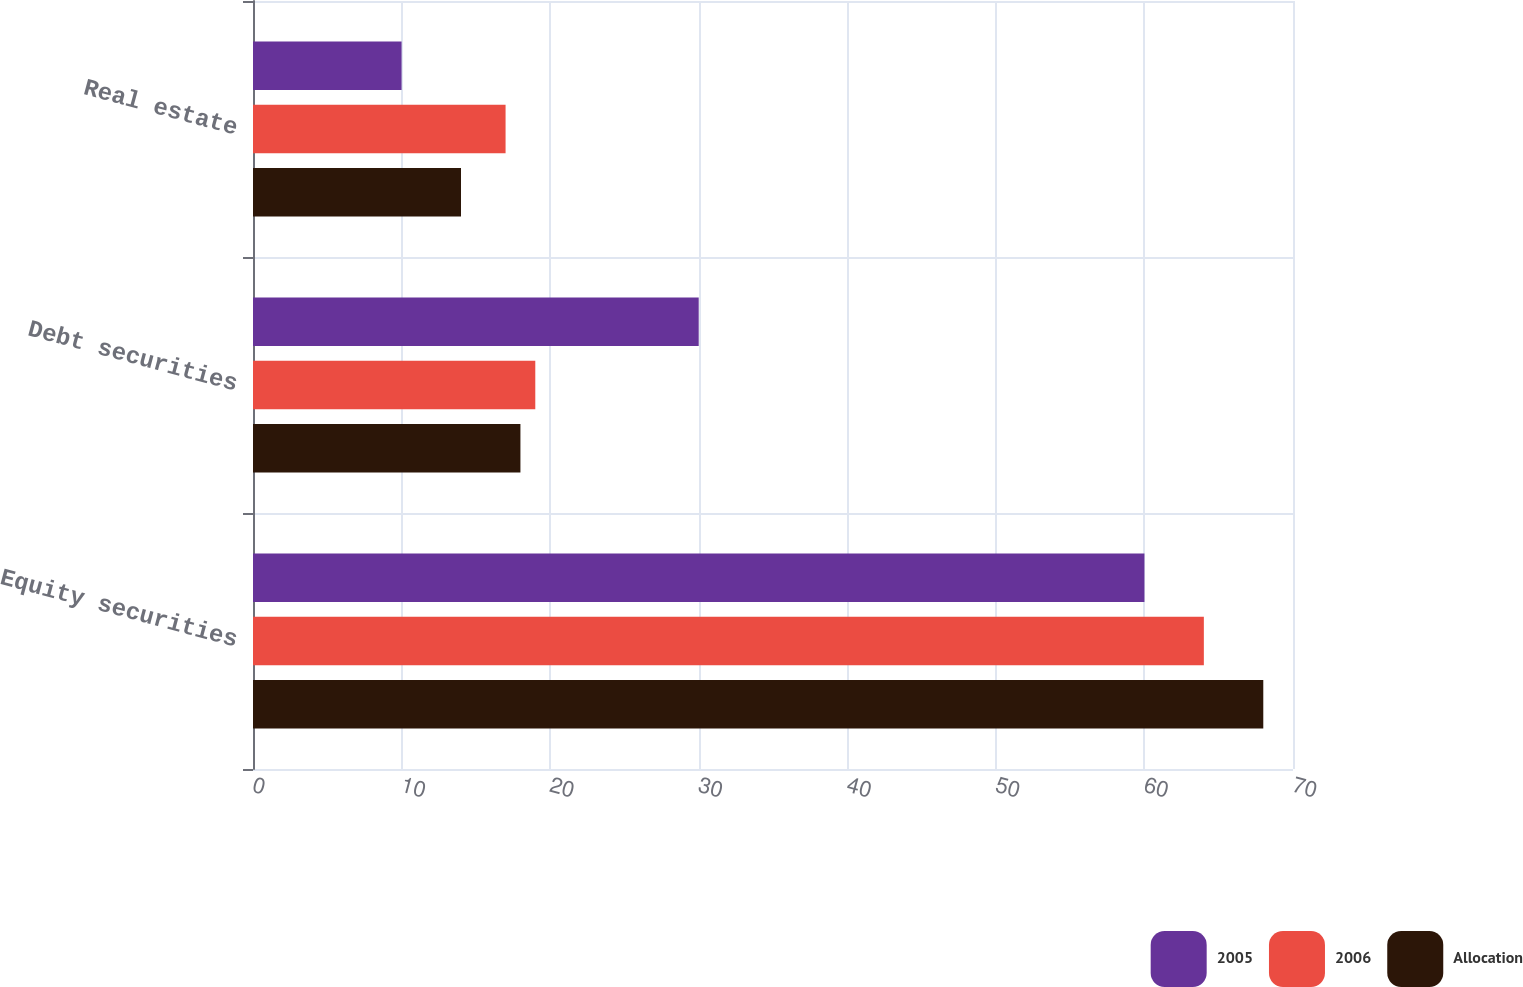<chart> <loc_0><loc_0><loc_500><loc_500><stacked_bar_chart><ecel><fcel>Equity securities<fcel>Debt securities<fcel>Real estate<nl><fcel>2005<fcel>60<fcel>30<fcel>10<nl><fcel>2006<fcel>64<fcel>19<fcel>17<nl><fcel>Allocation<fcel>68<fcel>18<fcel>14<nl></chart> 